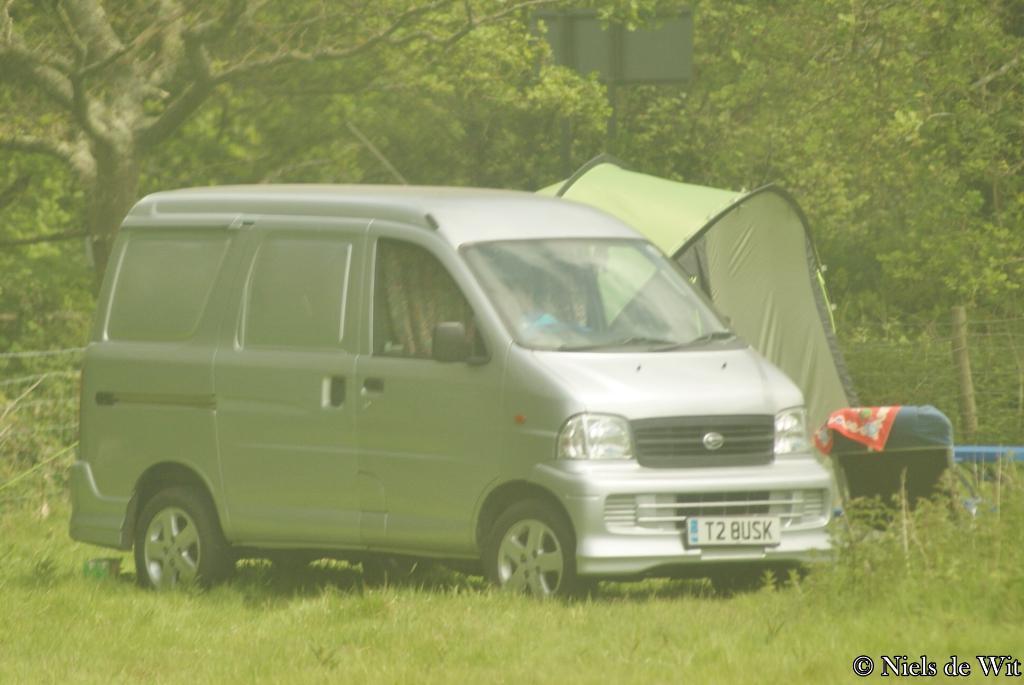What is the vehicles licence plate number?
Ensure brevity in your answer.  T2 busk. Who posted this picture?
Offer a terse response. Niels de wit. 